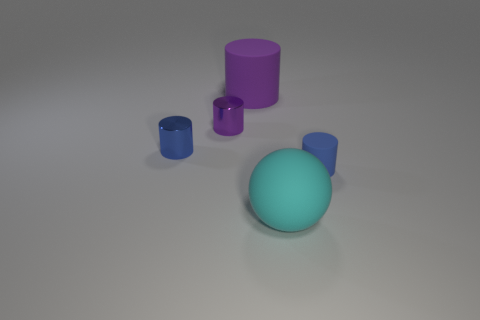Subtract 1 cylinders. How many cylinders are left? 3 Add 4 small purple metal spheres. How many objects exist? 9 Subtract all balls. How many objects are left? 4 Subtract 0 brown cylinders. How many objects are left? 5 Subtract all blue things. Subtract all tiny cylinders. How many objects are left? 0 Add 1 small cylinders. How many small cylinders are left? 4 Add 4 big rubber things. How many big rubber things exist? 6 